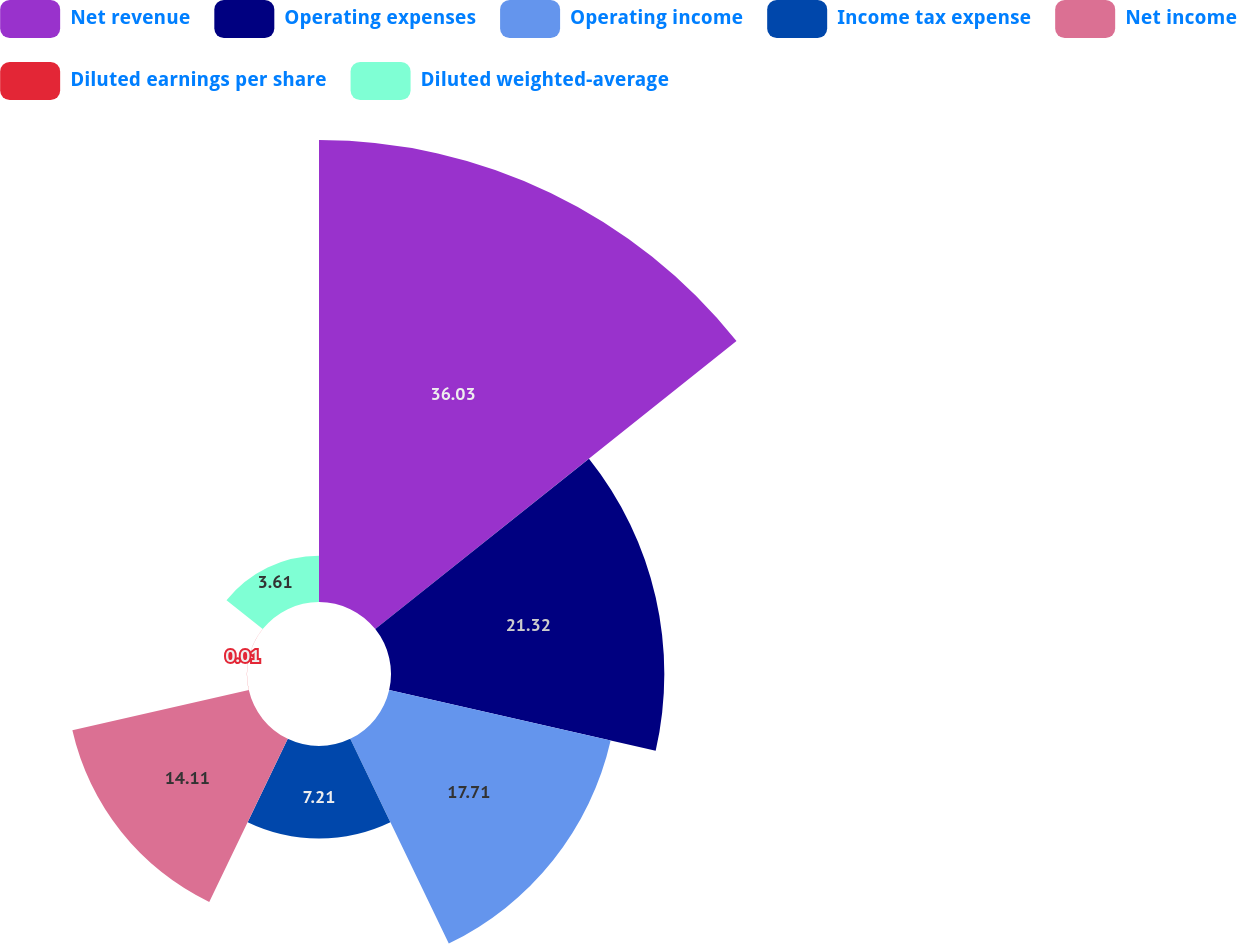Convert chart. <chart><loc_0><loc_0><loc_500><loc_500><pie_chart><fcel>Net revenue<fcel>Operating expenses<fcel>Operating income<fcel>Income tax expense<fcel>Net income<fcel>Diluted earnings per share<fcel>Diluted weighted-average<nl><fcel>36.02%<fcel>21.31%<fcel>17.71%<fcel>7.21%<fcel>14.11%<fcel>0.01%<fcel>3.61%<nl></chart> 